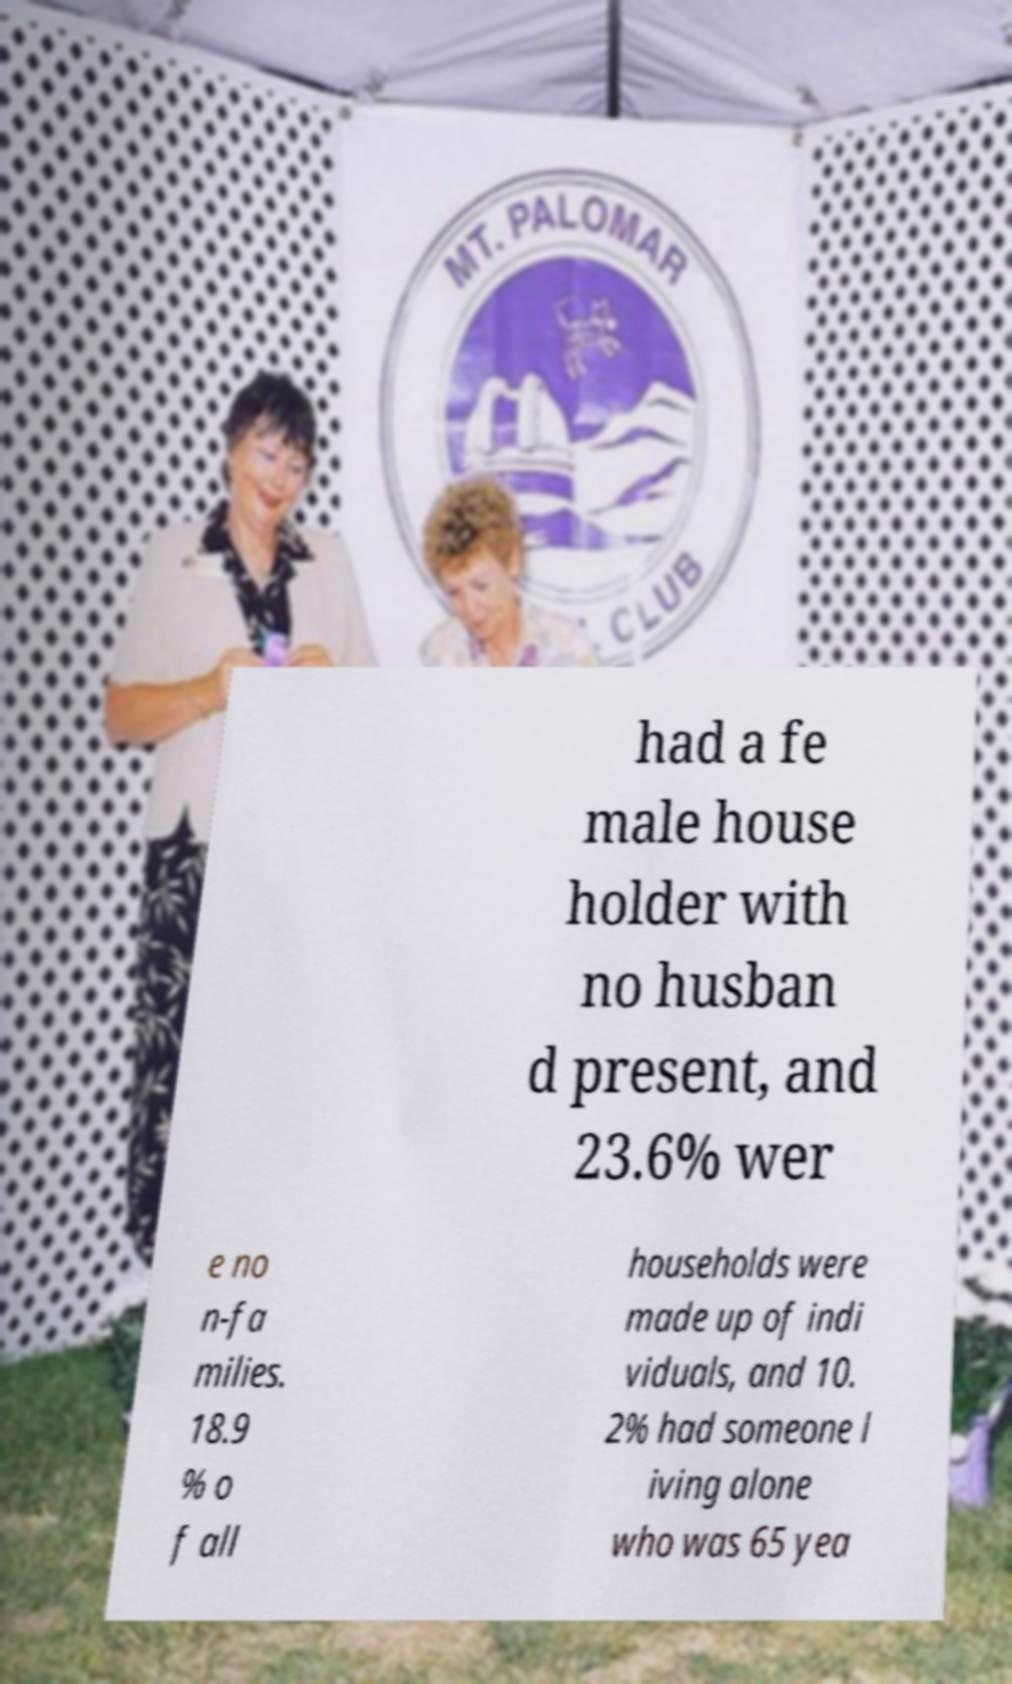Please identify and transcribe the text found in this image. had a fe male house holder with no husban d present, and 23.6% wer e no n-fa milies. 18.9 % o f all households were made up of indi viduals, and 10. 2% had someone l iving alone who was 65 yea 